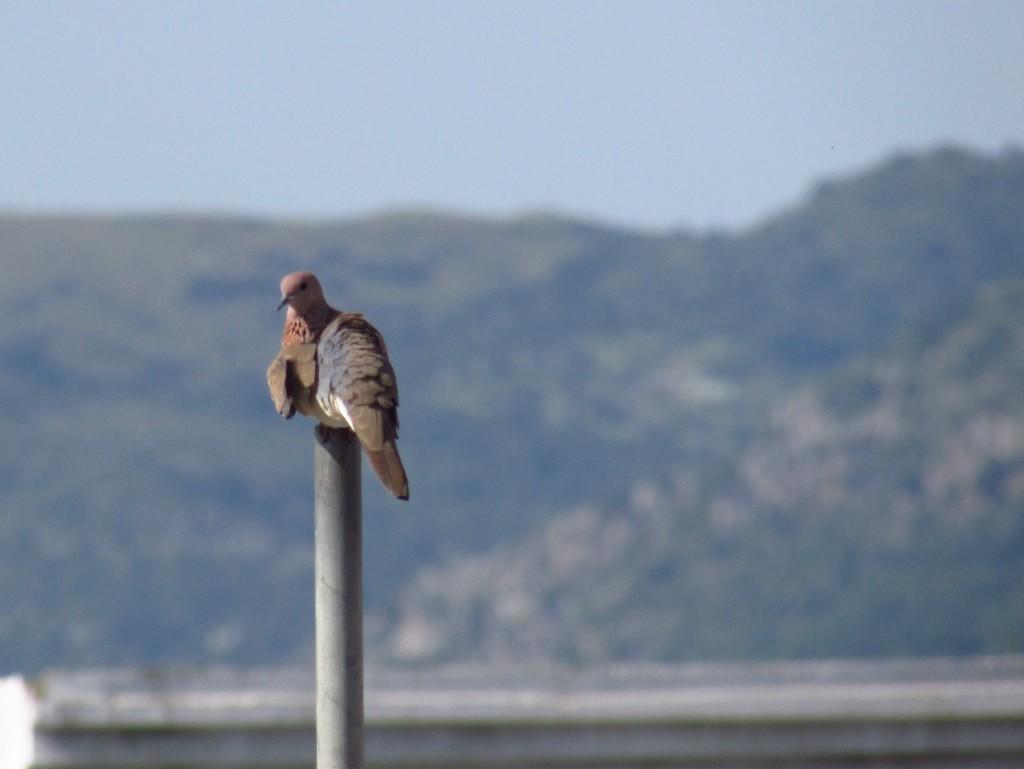Please provide a concise description of this image. In this image we can see a bird on the pole. In the background, we can see greenery. At the top of the image, we can see the sky. It seems like a wall at the bottom of the image. 